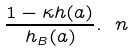<formula> <loc_0><loc_0><loc_500><loc_500>\frac { 1 - \kappa h ( a ) } { h _ { B } ( a ) } . \ n</formula> 